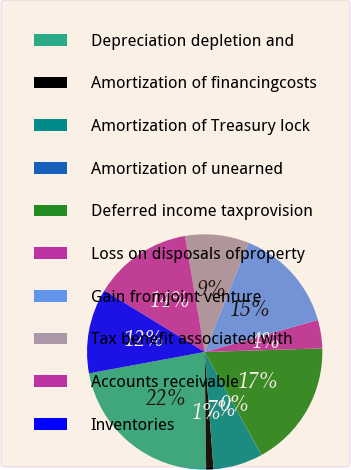Convert chart to OTSL. <chart><loc_0><loc_0><loc_500><loc_500><pie_chart><fcel>Depreciation depletion and<fcel>Amortization of financingcosts<fcel>Amortization of Treasury lock<fcel>Amortization of unearned<fcel>Deferred income taxprovision<fcel>Loss on disposals ofproperty<fcel>Gain fromjoint venture<fcel>Tax benefit associated with<fcel>Accounts receivable<fcel>Inventories<nl><fcel>22.29%<fcel>1.0%<fcel>6.81%<fcel>0.03%<fcel>17.45%<fcel>3.9%<fcel>14.55%<fcel>8.74%<fcel>13.58%<fcel>11.65%<nl></chart> 